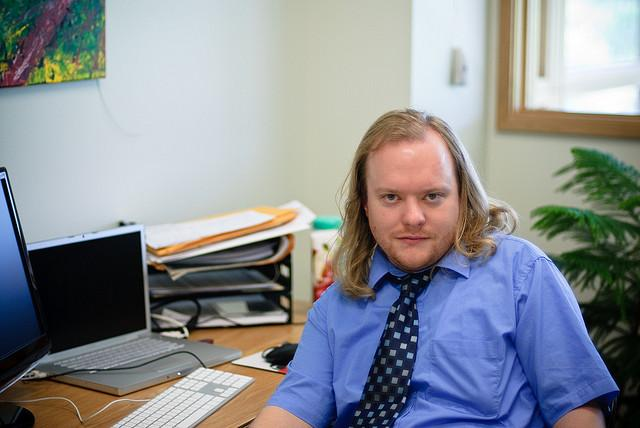What location does this man work in? Please explain your reasoning. office. The man is sitting near computers and documents. he is wearing business casual clothing. 